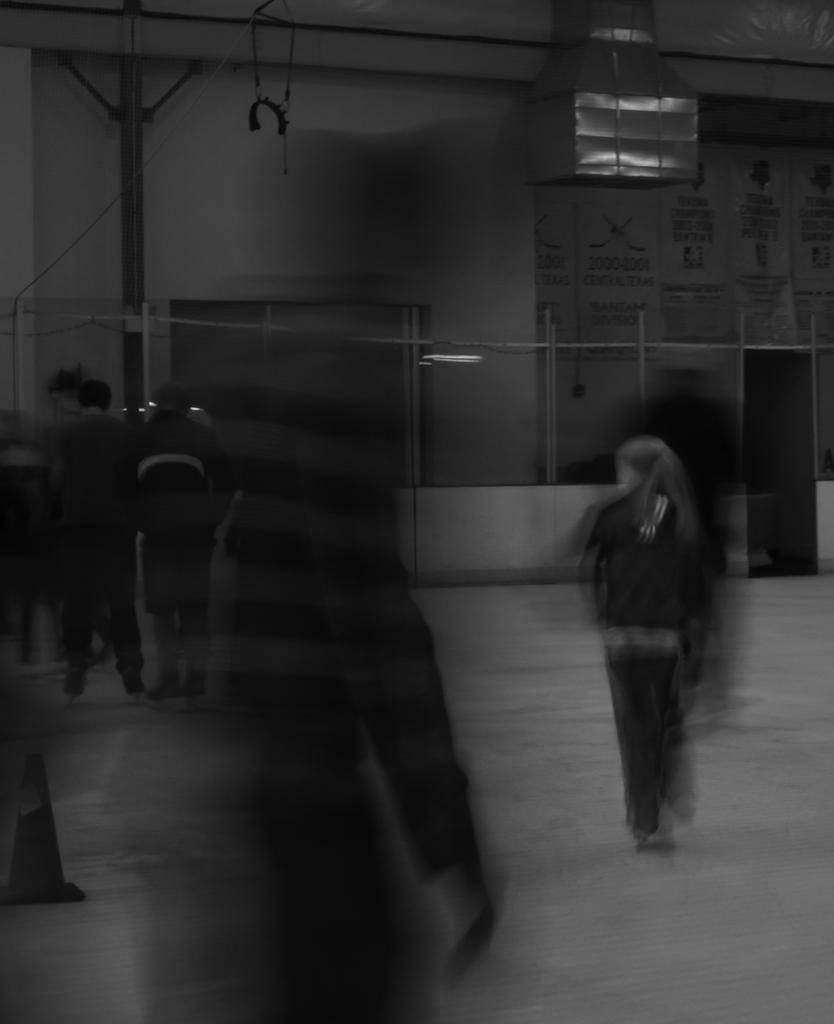How many people are in the image? There is a group of people in the image, but the exact number is not specified. What are the people in the image doing? The people are walking on the floor in the image. What can be seen in the background of the image? There is a wall, poles, ropes, a fence, and a machine in the background of the image. What type of crayon is being used by the people in the image? There is no crayon present in the image; the people are walking on the floor. What sound can be heard coming from the machine in the image? There is no sound mentioned in the image, and the specific function of the machine is not described. 